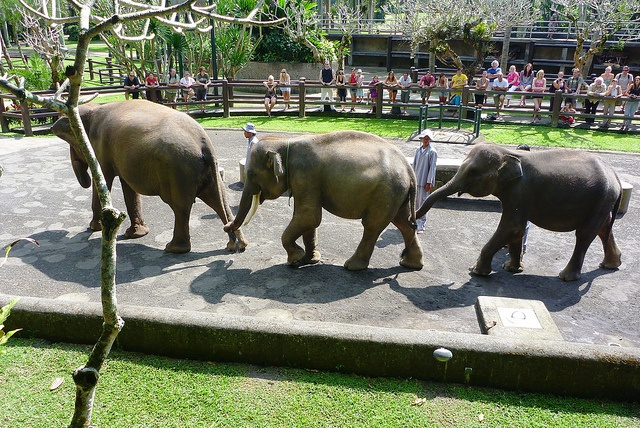Describe the objects in this image and their specific colors. I can see elephant in olive, black, darkgray, gray, and darkgreen tones, elephant in olive, black, darkgray, gray, and lightgray tones, elephant in olive, black, darkgray, darkgreen, and lightgray tones, people in olive, black, gray, darkgray, and lightgray tones, and people in olive, darkgray, gray, and white tones in this image. 